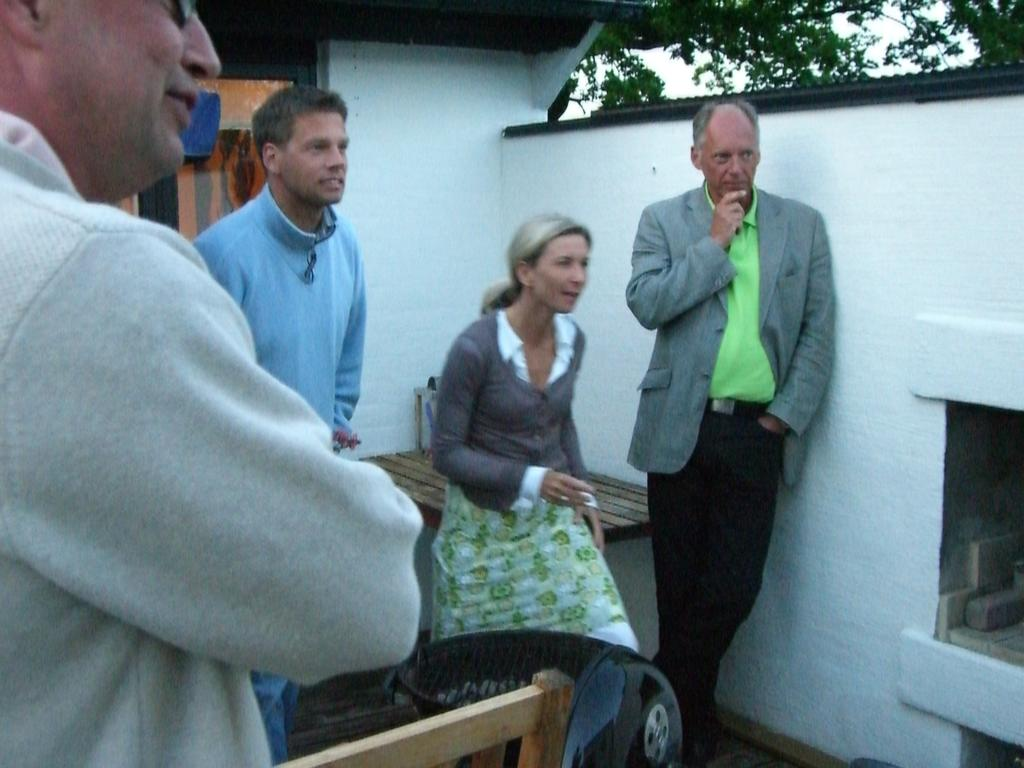What are the people in the image doing? The people in the image are standing in the balcony. What activity are the people engaged in while standing in the balcony? The people are talking to each other. What type of time is depicted in the image? There is no specific time depicted in the image; it only shows people standing in a balcony and talking to each other. Can you see a tray being carried by one of the people in the image? There is no tray visible in the image. 